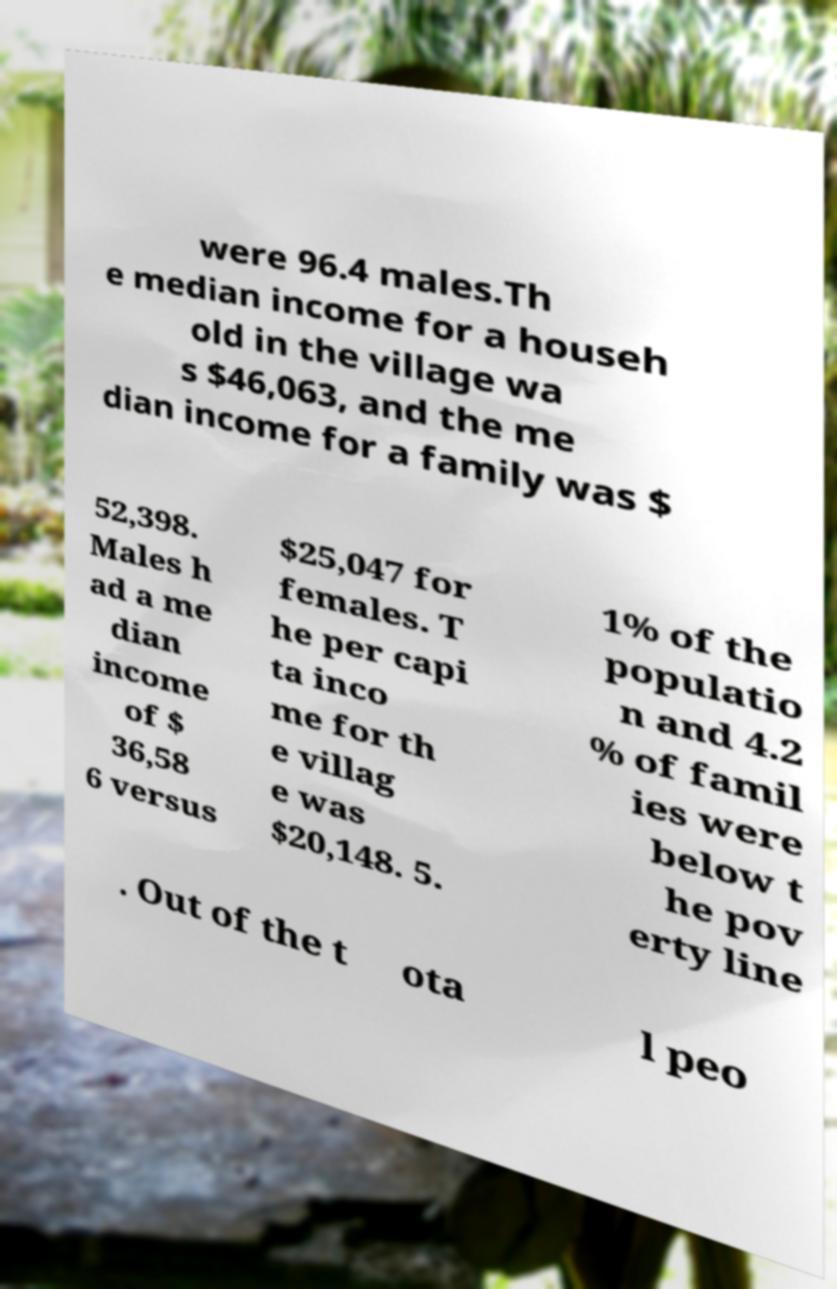Can you accurately transcribe the text from the provided image for me? were 96.4 males.Th e median income for a househ old in the village wa s $46,063, and the me dian income for a family was $ 52,398. Males h ad a me dian income of $ 36,58 6 versus $25,047 for females. T he per capi ta inco me for th e villag e was $20,148. 5. 1% of the populatio n and 4.2 % of famil ies were below t he pov erty line . Out of the t ota l peo 